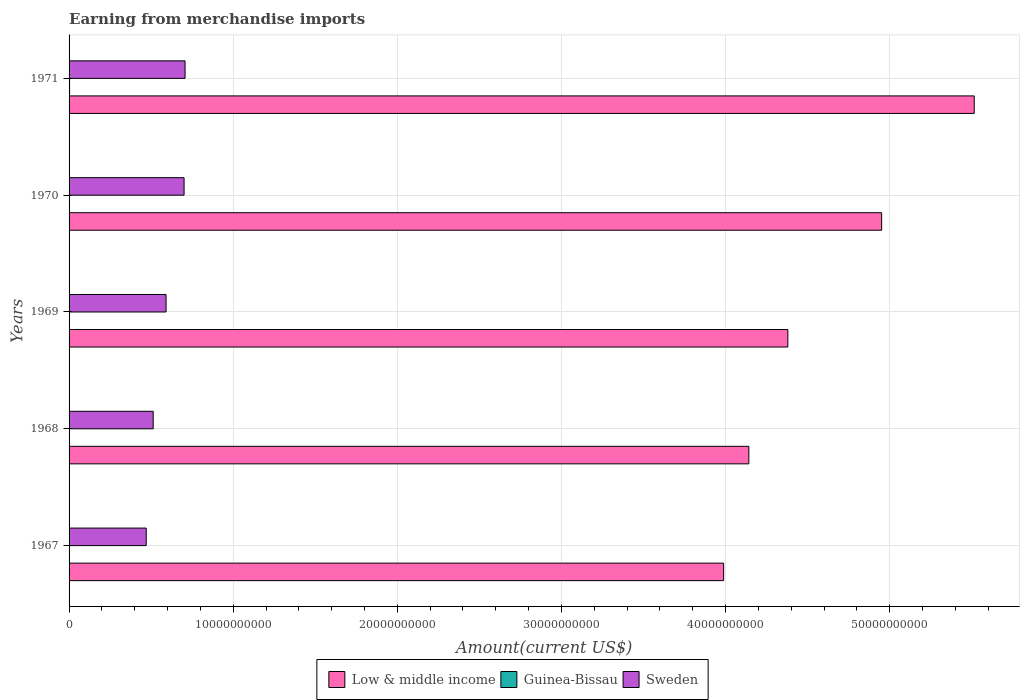Are the number of bars on each tick of the Y-axis equal?
Your answer should be compact. Yes. How many bars are there on the 1st tick from the top?
Offer a terse response. 3. What is the label of the 4th group of bars from the top?
Your answer should be very brief. 1968. What is the amount earned from merchandise imports in Low & middle income in 1969?
Your answer should be very brief. 4.38e+1. Across all years, what is the maximum amount earned from merchandise imports in Guinea-Bissau?
Keep it short and to the point. 3.11e+07. Across all years, what is the minimum amount earned from merchandise imports in Guinea-Bissau?
Your answer should be very brief. 1.64e+07. In which year was the amount earned from merchandise imports in Low & middle income maximum?
Ensure brevity in your answer.  1971. In which year was the amount earned from merchandise imports in Sweden minimum?
Ensure brevity in your answer.  1967. What is the total amount earned from merchandise imports in Sweden in the graph?
Keep it short and to the point. 2.98e+1. What is the difference between the amount earned from merchandise imports in Sweden in 1968 and that in 1969?
Provide a short and direct response. -7.84e+08. What is the difference between the amount earned from merchandise imports in Sweden in 1967 and the amount earned from merchandise imports in Low & middle income in 1968?
Your answer should be compact. -3.67e+1. What is the average amount earned from merchandise imports in Sweden per year?
Your answer should be very brief. 5.96e+09. In the year 1971, what is the difference between the amount earned from merchandise imports in Sweden and amount earned from merchandise imports in Guinea-Bissau?
Your answer should be compact. 7.04e+09. In how many years, is the amount earned from merchandise imports in Sweden greater than 14000000000 US$?
Offer a very short reply. 0. What is the ratio of the amount earned from merchandise imports in Guinea-Bissau in 1969 to that in 1971?
Offer a terse response. 0.75. Is the difference between the amount earned from merchandise imports in Sweden in 1969 and 1970 greater than the difference between the amount earned from merchandise imports in Guinea-Bissau in 1969 and 1970?
Provide a short and direct response. No. What is the difference between the highest and the second highest amount earned from merchandise imports in Low & middle income?
Make the answer very short. 5.64e+09. What is the difference between the highest and the lowest amount earned from merchandise imports in Sweden?
Provide a succinct answer. 2.37e+09. In how many years, is the amount earned from merchandise imports in Sweden greater than the average amount earned from merchandise imports in Sweden taken over all years?
Your answer should be very brief. 2. Is the sum of the amount earned from merchandise imports in Guinea-Bissau in 1968 and 1969 greater than the maximum amount earned from merchandise imports in Low & middle income across all years?
Provide a short and direct response. No. What does the 1st bar from the top in 1969 represents?
Provide a succinct answer. Sweden. What does the 2nd bar from the bottom in 1967 represents?
Your answer should be compact. Guinea-Bissau. How many bars are there?
Offer a terse response. 15. Are all the bars in the graph horizontal?
Your answer should be compact. Yes. What is the difference between two consecutive major ticks on the X-axis?
Offer a very short reply. 1.00e+1. Does the graph contain grids?
Your answer should be very brief. Yes. Where does the legend appear in the graph?
Keep it short and to the point. Bottom center. How many legend labels are there?
Ensure brevity in your answer.  3. How are the legend labels stacked?
Keep it short and to the point. Horizontal. What is the title of the graph?
Provide a short and direct response. Earning from merchandise imports. What is the label or title of the X-axis?
Provide a succinct answer. Amount(current US$). What is the Amount(current US$) of Low & middle income in 1967?
Your answer should be very brief. 3.99e+1. What is the Amount(current US$) of Guinea-Bissau in 1967?
Offer a terse response. 1.64e+07. What is the Amount(current US$) of Sweden in 1967?
Your answer should be compact. 4.70e+09. What is the Amount(current US$) of Low & middle income in 1968?
Provide a succinct answer. 4.14e+1. What is the Amount(current US$) of Guinea-Bissau in 1968?
Your answer should be very brief. 1.76e+07. What is the Amount(current US$) of Sweden in 1968?
Make the answer very short. 5.13e+09. What is the Amount(current US$) in Low & middle income in 1969?
Ensure brevity in your answer.  4.38e+1. What is the Amount(current US$) in Guinea-Bissau in 1969?
Ensure brevity in your answer.  2.34e+07. What is the Amount(current US$) of Sweden in 1969?
Provide a short and direct response. 5.91e+09. What is the Amount(current US$) of Low & middle income in 1970?
Offer a terse response. 4.95e+1. What is the Amount(current US$) of Guinea-Bissau in 1970?
Offer a very short reply. 2.73e+07. What is the Amount(current US$) of Sweden in 1970?
Provide a succinct answer. 7.01e+09. What is the Amount(current US$) of Low & middle income in 1971?
Keep it short and to the point. 5.52e+1. What is the Amount(current US$) of Guinea-Bissau in 1971?
Offer a terse response. 3.11e+07. What is the Amount(current US$) of Sweden in 1971?
Offer a very short reply. 7.07e+09. Across all years, what is the maximum Amount(current US$) of Low & middle income?
Ensure brevity in your answer.  5.52e+1. Across all years, what is the maximum Amount(current US$) of Guinea-Bissau?
Offer a very short reply. 3.11e+07. Across all years, what is the maximum Amount(current US$) in Sweden?
Offer a terse response. 7.07e+09. Across all years, what is the minimum Amount(current US$) in Low & middle income?
Ensure brevity in your answer.  3.99e+1. Across all years, what is the minimum Amount(current US$) in Guinea-Bissau?
Your answer should be very brief. 1.64e+07. Across all years, what is the minimum Amount(current US$) of Sweden?
Ensure brevity in your answer.  4.70e+09. What is the total Amount(current US$) in Low & middle income in the graph?
Give a very brief answer. 2.30e+11. What is the total Amount(current US$) in Guinea-Bissau in the graph?
Your answer should be very brief. 1.16e+08. What is the total Amount(current US$) in Sweden in the graph?
Make the answer very short. 2.98e+1. What is the difference between the Amount(current US$) in Low & middle income in 1967 and that in 1968?
Provide a short and direct response. -1.54e+09. What is the difference between the Amount(current US$) in Guinea-Bissau in 1967 and that in 1968?
Your answer should be compact. -1.21e+06. What is the difference between the Amount(current US$) of Sweden in 1967 and that in 1968?
Give a very brief answer. -4.25e+08. What is the difference between the Amount(current US$) in Low & middle income in 1967 and that in 1969?
Give a very brief answer. -3.91e+09. What is the difference between the Amount(current US$) of Guinea-Bissau in 1967 and that in 1969?
Your response must be concise. -6.97e+06. What is the difference between the Amount(current US$) in Sweden in 1967 and that in 1969?
Your answer should be very brief. -1.21e+09. What is the difference between the Amount(current US$) of Low & middle income in 1967 and that in 1970?
Keep it short and to the point. -9.63e+09. What is the difference between the Amount(current US$) of Guinea-Bissau in 1967 and that in 1970?
Offer a terse response. -1.09e+07. What is the difference between the Amount(current US$) in Sweden in 1967 and that in 1970?
Your answer should be compact. -2.31e+09. What is the difference between the Amount(current US$) of Low & middle income in 1967 and that in 1971?
Give a very brief answer. -1.53e+1. What is the difference between the Amount(current US$) of Guinea-Bissau in 1967 and that in 1971?
Your response must be concise. -1.46e+07. What is the difference between the Amount(current US$) of Sweden in 1967 and that in 1971?
Provide a short and direct response. -2.37e+09. What is the difference between the Amount(current US$) in Low & middle income in 1968 and that in 1969?
Ensure brevity in your answer.  -2.38e+09. What is the difference between the Amount(current US$) of Guinea-Bissau in 1968 and that in 1969?
Give a very brief answer. -5.76e+06. What is the difference between the Amount(current US$) of Sweden in 1968 and that in 1969?
Give a very brief answer. -7.84e+08. What is the difference between the Amount(current US$) in Low & middle income in 1968 and that in 1970?
Your response must be concise. -8.09e+09. What is the difference between the Amount(current US$) of Guinea-Bissau in 1968 and that in 1970?
Ensure brevity in your answer.  -9.71e+06. What is the difference between the Amount(current US$) in Sweden in 1968 and that in 1970?
Offer a terse response. -1.88e+09. What is the difference between the Amount(current US$) of Low & middle income in 1968 and that in 1971?
Your response must be concise. -1.37e+1. What is the difference between the Amount(current US$) in Guinea-Bissau in 1968 and that in 1971?
Provide a succinct answer. -1.34e+07. What is the difference between the Amount(current US$) in Sweden in 1968 and that in 1971?
Your response must be concise. -1.94e+09. What is the difference between the Amount(current US$) in Low & middle income in 1969 and that in 1970?
Your answer should be very brief. -5.72e+09. What is the difference between the Amount(current US$) of Guinea-Bissau in 1969 and that in 1970?
Provide a short and direct response. -3.95e+06. What is the difference between the Amount(current US$) of Sweden in 1969 and that in 1970?
Your answer should be compact. -1.10e+09. What is the difference between the Amount(current US$) in Low & middle income in 1969 and that in 1971?
Make the answer very short. -1.14e+1. What is the difference between the Amount(current US$) in Guinea-Bissau in 1969 and that in 1971?
Offer a terse response. -7.67e+06. What is the difference between the Amount(current US$) of Sweden in 1969 and that in 1971?
Offer a very short reply. -1.16e+09. What is the difference between the Amount(current US$) in Low & middle income in 1970 and that in 1971?
Keep it short and to the point. -5.64e+09. What is the difference between the Amount(current US$) in Guinea-Bissau in 1970 and that in 1971?
Your response must be concise. -3.72e+06. What is the difference between the Amount(current US$) of Sweden in 1970 and that in 1971?
Provide a succinct answer. -5.94e+07. What is the difference between the Amount(current US$) of Low & middle income in 1967 and the Amount(current US$) of Guinea-Bissau in 1968?
Provide a short and direct response. 3.99e+1. What is the difference between the Amount(current US$) of Low & middle income in 1967 and the Amount(current US$) of Sweden in 1968?
Keep it short and to the point. 3.48e+1. What is the difference between the Amount(current US$) of Guinea-Bissau in 1967 and the Amount(current US$) of Sweden in 1968?
Ensure brevity in your answer.  -5.11e+09. What is the difference between the Amount(current US$) of Low & middle income in 1967 and the Amount(current US$) of Guinea-Bissau in 1969?
Your answer should be compact. 3.99e+1. What is the difference between the Amount(current US$) of Low & middle income in 1967 and the Amount(current US$) of Sweden in 1969?
Offer a very short reply. 3.40e+1. What is the difference between the Amount(current US$) in Guinea-Bissau in 1967 and the Amount(current US$) in Sweden in 1969?
Provide a short and direct response. -5.89e+09. What is the difference between the Amount(current US$) of Low & middle income in 1967 and the Amount(current US$) of Guinea-Bissau in 1970?
Offer a terse response. 3.99e+1. What is the difference between the Amount(current US$) in Low & middle income in 1967 and the Amount(current US$) in Sweden in 1970?
Your answer should be compact. 3.29e+1. What is the difference between the Amount(current US$) of Guinea-Bissau in 1967 and the Amount(current US$) of Sweden in 1970?
Your answer should be compact. -6.99e+09. What is the difference between the Amount(current US$) of Low & middle income in 1967 and the Amount(current US$) of Guinea-Bissau in 1971?
Ensure brevity in your answer.  3.99e+1. What is the difference between the Amount(current US$) of Low & middle income in 1967 and the Amount(current US$) of Sweden in 1971?
Provide a succinct answer. 3.28e+1. What is the difference between the Amount(current US$) of Guinea-Bissau in 1967 and the Amount(current US$) of Sweden in 1971?
Offer a very short reply. -7.05e+09. What is the difference between the Amount(current US$) in Low & middle income in 1968 and the Amount(current US$) in Guinea-Bissau in 1969?
Your answer should be compact. 4.14e+1. What is the difference between the Amount(current US$) in Low & middle income in 1968 and the Amount(current US$) in Sweden in 1969?
Provide a short and direct response. 3.55e+1. What is the difference between the Amount(current US$) of Guinea-Bissau in 1968 and the Amount(current US$) of Sweden in 1969?
Offer a terse response. -5.89e+09. What is the difference between the Amount(current US$) in Low & middle income in 1968 and the Amount(current US$) in Guinea-Bissau in 1970?
Your answer should be very brief. 4.14e+1. What is the difference between the Amount(current US$) of Low & middle income in 1968 and the Amount(current US$) of Sweden in 1970?
Offer a terse response. 3.44e+1. What is the difference between the Amount(current US$) of Guinea-Bissau in 1968 and the Amount(current US$) of Sweden in 1970?
Keep it short and to the point. -6.99e+09. What is the difference between the Amount(current US$) of Low & middle income in 1968 and the Amount(current US$) of Guinea-Bissau in 1971?
Make the answer very short. 4.14e+1. What is the difference between the Amount(current US$) in Low & middle income in 1968 and the Amount(current US$) in Sweden in 1971?
Give a very brief answer. 3.44e+1. What is the difference between the Amount(current US$) of Guinea-Bissau in 1968 and the Amount(current US$) of Sweden in 1971?
Offer a terse response. -7.05e+09. What is the difference between the Amount(current US$) of Low & middle income in 1969 and the Amount(current US$) of Guinea-Bissau in 1970?
Offer a very short reply. 4.38e+1. What is the difference between the Amount(current US$) in Low & middle income in 1969 and the Amount(current US$) in Sweden in 1970?
Ensure brevity in your answer.  3.68e+1. What is the difference between the Amount(current US$) in Guinea-Bissau in 1969 and the Amount(current US$) in Sweden in 1970?
Offer a terse response. -6.98e+09. What is the difference between the Amount(current US$) in Low & middle income in 1969 and the Amount(current US$) in Guinea-Bissau in 1971?
Keep it short and to the point. 4.38e+1. What is the difference between the Amount(current US$) of Low & middle income in 1969 and the Amount(current US$) of Sweden in 1971?
Your answer should be very brief. 3.67e+1. What is the difference between the Amount(current US$) of Guinea-Bissau in 1969 and the Amount(current US$) of Sweden in 1971?
Your answer should be compact. -7.04e+09. What is the difference between the Amount(current US$) in Low & middle income in 1970 and the Amount(current US$) in Guinea-Bissau in 1971?
Offer a terse response. 4.95e+1. What is the difference between the Amount(current US$) in Low & middle income in 1970 and the Amount(current US$) in Sweden in 1971?
Ensure brevity in your answer.  4.24e+1. What is the difference between the Amount(current US$) in Guinea-Bissau in 1970 and the Amount(current US$) in Sweden in 1971?
Give a very brief answer. -7.04e+09. What is the average Amount(current US$) of Low & middle income per year?
Provide a succinct answer. 4.60e+1. What is the average Amount(current US$) of Guinea-Bissau per year?
Offer a terse response. 2.32e+07. What is the average Amount(current US$) in Sweden per year?
Keep it short and to the point. 5.96e+09. In the year 1967, what is the difference between the Amount(current US$) in Low & middle income and Amount(current US$) in Guinea-Bissau?
Ensure brevity in your answer.  3.99e+1. In the year 1967, what is the difference between the Amount(current US$) in Low & middle income and Amount(current US$) in Sweden?
Your answer should be very brief. 3.52e+1. In the year 1967, what is the difference between the Amount(current US$) in Guinea-Bissau and Amount(current US$) in Sweden?
Provide a short and direct response. -4.68e+09. In the year 1968, what is the difference between the Amount(current US$) of Low & middle income and Amount(current US$) of Guinea-Bissau?
Your answer should be very brief. 4.14e+1. In the year 1968, what is the difference between the Amount(current US$) of Low & middle income and Amount(current US$) of Sweden?
Your answer should be very brief. 3.63e+1. In the year 1968, what is the difference between the Amount(current US$) in Guinea-Bissau and Amount(current US$) in Sweden?
Keep it short and to the point. -5.11e+09. In the year 1969, what is the difference between the Amount(current US$) of Low & middle income and Amount(current US$) of Guinea-Bissau?
Give a very brief answer. 4.38e+1. In the year 1969, what is the difference between the Amount(current US$) in Low & middle income and Amount(current US$) in Sweden?
Your answer should be compact. 3.79e+1. In the year 1969, what is the difference between the Amount(current US$) of Guinea-Bissau and Amount(current US$) of Sweden?
Ensure brevity in your answer.  -5.89e+09. In the year 1970, what is the difference between the Amount(current US$) of Low & middle income and Amount(current US$) of Guinea-Bissau?
Offer a terse response. 4.95e+1. In the year 1970, what is the difference between the Amount(current US$) of Low & middle income and Amount(current US$) of Sweden?
Ensure brevity in your answer.  4.25e+1. In the year 1970, what is the difference between the Amount(current US$) of Guinea-Bissau and Amount(current US$) of Sweden?
Make the answer very short. -6.98e+09. In the year 1971, what is the difference between the Amount(current US$) in Low & middle income and Amount(current US$) in Guinea-Bissau?
Offer a very short reply. 5.51e+1. In the year 1971, what is the difference between the Amount(current US$) in Low & middle income and Amount(current US$) in Sweden?
Keep it short and to the point. 4.81e+1. In the year 1971, what is the difference between the Amount(current US$) of Guinea-Bissau and Amount(current US$) of Sweden?
Offer a terse response. -7.04e+09. What is the ratio of the Amount(current US$) of Low & middle income in 1967 to that in 1968?
Ensure brevity in your answer.  0.96. What is the ratio of the Amount(current US$) of Guinea-Bissau in 1967 to that in 1968?
Make the answer very short. 0.93. What is the ratio of the Amount(current US$) of Sweden in 1967 to that in 1968?
Provide a short and direct response. 0.92. What is the ratio of the Amount(current US$) in Low & middle income in 1967 to that in 1969?
Your answer should be compact. 0.91. What is the ratio of the Amount(current US$) of Guinea-Bissau in 1967 to that in 1969?
Provide a short and direct response. 0.7. What is the ratio of the Amount(current US$) of Sweden in 1967 to that in 1969?
Keep it short and to the point. 0.8. What is the ratio of the Amount(current US$) in Low & middle income in 1967 to that in 1970?
Give a very brief answer. 0.81. What is the ratio of the Amount(current US$) of Guinea-Bissau in 1967 to that in 1970?
Keep it short and to the point. 0.6. What is the ratio of the Amount(current US$) of Sweden in 1967 to that in 1970?
Offer a terse response. 0.67. What is the ratio of the Amount(current US$) in Low & middle income in 1967 to that in 1971?
Offer a terse response. 0.72. What is the ratio of the Amount(current US$) in Guinea-Bissau in 1967 to that in 1971?
Your answer should be very brief. 0.53. What is the ratio of the Amount(current US$) of Sweden in 1967 to that in 1971?
Your answer should be very brief. 0.67. What is the ratio of the Amount(current US$) in Low & middle income in 1968 to that in 1969?
Your response must be concise. 0.95. What is the ratio of the Amount(current US$) in Guinea-Bissau in 1968 to that in 1969?
Provide a succinct answer. 0.75. What is the ratio of the Amount(current US$) of Sweden in 1968 to that in 1969?
Give a very brief answer. 0.87. What is the ratio of the Amount(current US$) in Low & middle income in 1968 to that in 1970?
Provide a succinct answer. 0.84. What is the ratio of the Amount(current US$) in Guinea-Bissau in 1968 to that in 1970?
Your answer should be very brief. 0.64. What is the ratio of the Amount(current US$) in Sweden in 1968 to that in 1970?
Your answer should be compact. 0.73. What is the ratio of the Amount(current US$) in Low & middle income in 1968 to that in 1971?
Offer a very short reply. 0.75. What is the ratio of the Amount(current US$) in Guinea-Bissau in 1968 to that in 1971?
Give a very brief answer. 0.57. What is the ratio of the Amount(current US$) of Sweden in 1968 to that in 1971?
Ensure brevity in your answer.  0.73. What is the ratio of the Amount(current US$) in Low & middle income in 1969 to that in 1970?
Your answer should be compact. 0.88. What is the ratio of the Amount(current US$) in Guinea-Bissau in 1969 to that in 1970?
Give a very brief answer. 0.86. What is the ratio of the Amount(current US$) of Sweden in 1969 to that in 1970?
Your answer should be very brief. 0.84. What is the ratio of the Amount(current US$) in Low & middle income in 1969 to that in 1971?
Your response must be concise. 0.79. What is the ratio of the Amount(current US$) of Guinea-Bissau in 1969 to that in 1971?
Keep it short and to the point. 0.75. What is the ratio of the Amount(current US$) in Sweden in 1969 to that in 1971?
Give a very brief answer. 0.84. What is the ratio of the Amount(current US$) of Low & middle income in 1970 to that in 1971?
Make the answer very short. 0.9. What is the ratio of the Amount(current US$) in Guinea-Bissau in 1970 to that in 1971?
Provide a succinct answer. 0.88. What is the ratio of the Amount(current US$) of Sweden in 1970 to that in 1971?
Your answer should be compact. 0.99. What is the difference between the highest and the second highest Amount(current US$) in Low & middle income?
Provide a short and direct response. 5.64e+09. What is the difference between the highest and the second highest Amount(current US$) of Guinea-Bissau?
Keep it short and to the point. 3.72e+06. What is the difference between the highest and the second highest Amount(current US$) of Sweden?
Your response must be concise. 5.94e+07. What is the difference between the highest and the lowest Amount(current US$) of Low & middle income?
Ensure brevity in your answer.  1.53e+1. What is the difference between the highest and the lowest Amount(current US$) of Guinea-Bissau?
Your answer should be very brief. 1.46e+07. What is the difference between the highest and the lowest Amount(current US$) of Sweden?
Offer a terse response. 2.37e+09. 